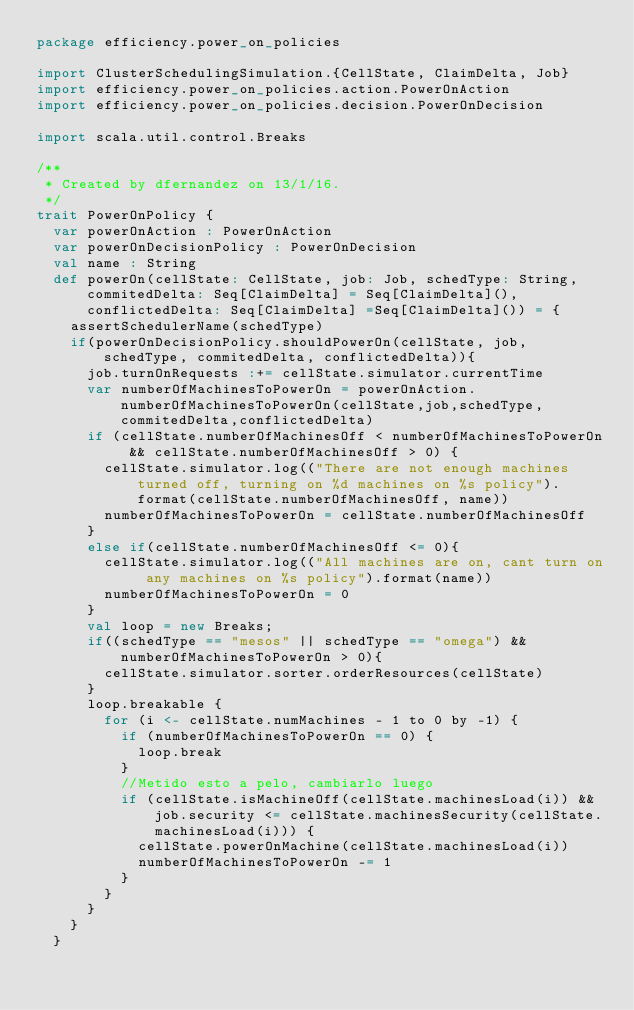<code> <loc_0><loc_0><loc_500><loc_500><_Scala_>package efficiency.power_on_policies

import ClusterSchedulingSimulation.{CellState, ClaimDelta, Job}
import efficiency.power_on_policies.action.PowerOnAction
import efficiency.power_on_policies.decision.PowerOnDecision

import scala.util.control.Breaks

/**
 * Created by dfernandez on 13/1/16.
 */
trait PowerOnPolicy {
  var powerOnAction : PowerOnAction
  var powerOnDecisionPolicy : PowerOnDecision
  val name : String
  def powerOn(cellState: CellState, job: Job, schedType: String, commitedDelta: Seq[ClaimDelta] = Seq[ClaimDelta](), conflictedDelta: Seq[ClaimDelta] =Seq[ClaimDelta]()) = {
    assertSchedulerName(schedType)
    if(powerOnDecisionPolicy.shouldPowerOn(cellState, job, schedType, commitedDelta, conflictedDelta)){
      job.turnOnRequests :+= cellState.simulator.currentTime
      var numberOfMachinesToPowerOn = powerOnAction.numberOfMachinesToPowerOn(cellState,job,schedType,commitedDelta,conflictedDelta)
      if (cellState.numberOfMachinesOff < numberOfMachinesToPowerOn && cellState.numberOfMachinesOff > 0) {
        cellState.simulator.log(("There are not enough machines turned off, turning on %d machines on %s policy").format(cellState.numberOfMachinesOff, name))
        numberOfMachinesToPowerOn = cellState.numberOfMachinesOff
      }
      else if(cellState.numberOfMachinesOff <= 0){
        cellState.simulator.log(("All machines are on, cant turn on any machines on %s policy").format(name))
        numberOfMachinesToPowerOn = 0
      }
      val loop = new Breaks;
      if((schedType == "mesos" || schedType == "omega") && numberOfMachinesToPowerOn > 0){
        cellState.simulator.sorter.orderResources(cellState)
      }
      loop.breakable {
        for (i <- cellState.numMachines - 1 to 0 by -1) {
          if (numberOfMachinesToPowerOn == 0) {
            loop.break
          }
          //Metido esto a pelo, cambiarlo luego
          if (cellState.isMachineOff(cellState.machinesLoad(i)) && job.security <= cellState.machinesSecurity(cellState.machinesLoad(i))) {
            cellState.powerOnMachine(cellState.machinesLoad(i))
            numberOfMachinesToPowerOn -= 1
          }
        }
      }
    }
  }</code> 